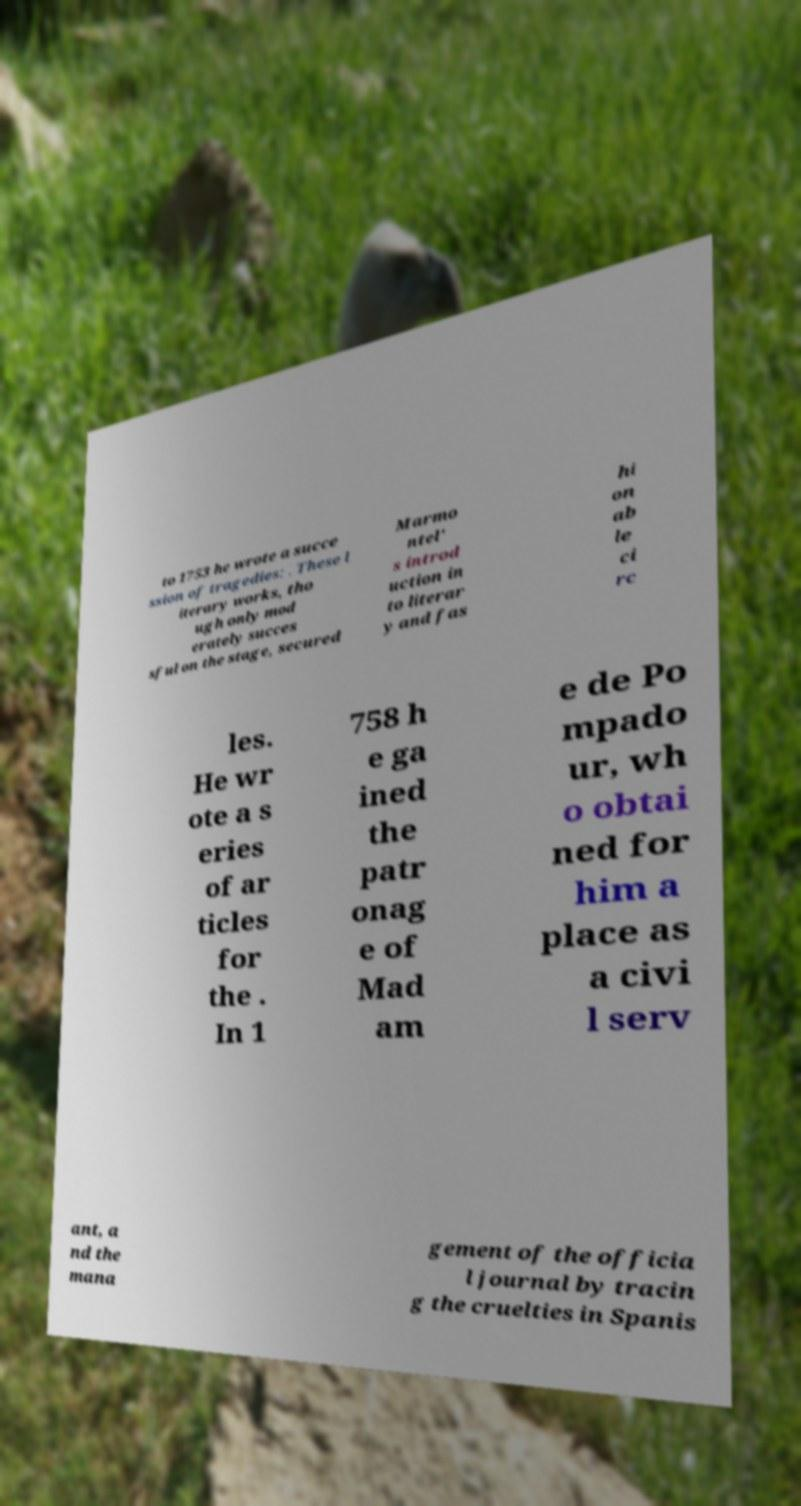Can you accurately transcribe the text from the provided image for me? to 1753 he wrote a succe ssion of tragedies: . These l iterary works, tho ugh only mod erately succes sful on the stage, secured Marmo ntel' s introd uction in to literar y and fas hi on ab le ci rc les. He wr ote a s eries of ar ticles for the . In 1 758 h e ga ined the patr onag e of Mad am e de Po mpado ur, wh o obtai ned for him a place as a civi l serv ant, a nd the mana gement of the officia l journal by tracin g the cruelties in Spanis 